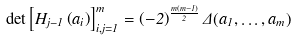<formula> <loc_0><loc_0><loc_500><loc_500>\det \left [ H _ { j - 1 } \left ( a _ { i } \right ) \right ] _ { i , j = 1 } ^ { m } = \left ( - 2 \right ) ^ { \frac { m \left ( m - 1 \right ) } { 2 } } \Delta ( a _ { 1 } , \dots , a _ { m } )</formula> 